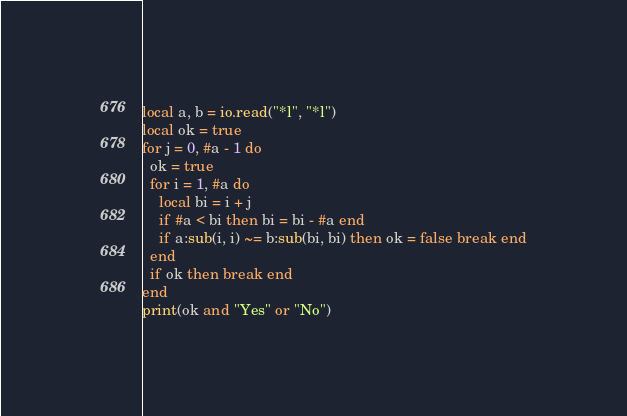Convert code to text. <code><loc_0><loc_0><loc_500><loc_500><_Lua_>local a, b = io.read("*l", "*l")
local ok = true
for j = 0, #a - 1 do
  ok = true
  for i = 1, #a do
    local bi = i + j
    if #a < bi then bi = bi - #a end
    if a:sub(i, i) ~= b:sub(bi, bi) then ok = false break end
  end
  if ok then break end
end
print(ok and "Yes" or "No")
</code> 